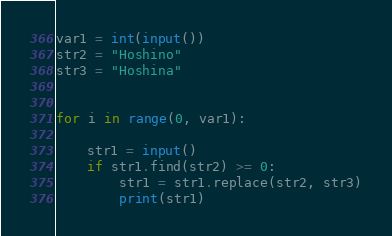<code> <loc_0><loc_0><loc_500><loc_500><_Python_>var1 = int(input())
str2 = "Hoshino"
str3 = "Hoshina"


for i in range(0, var1):

    str1 = input()
    if str1.find(str2) >= 0:
        str1 = str1.replace(str2, str3)
        print(str1)


</code> 